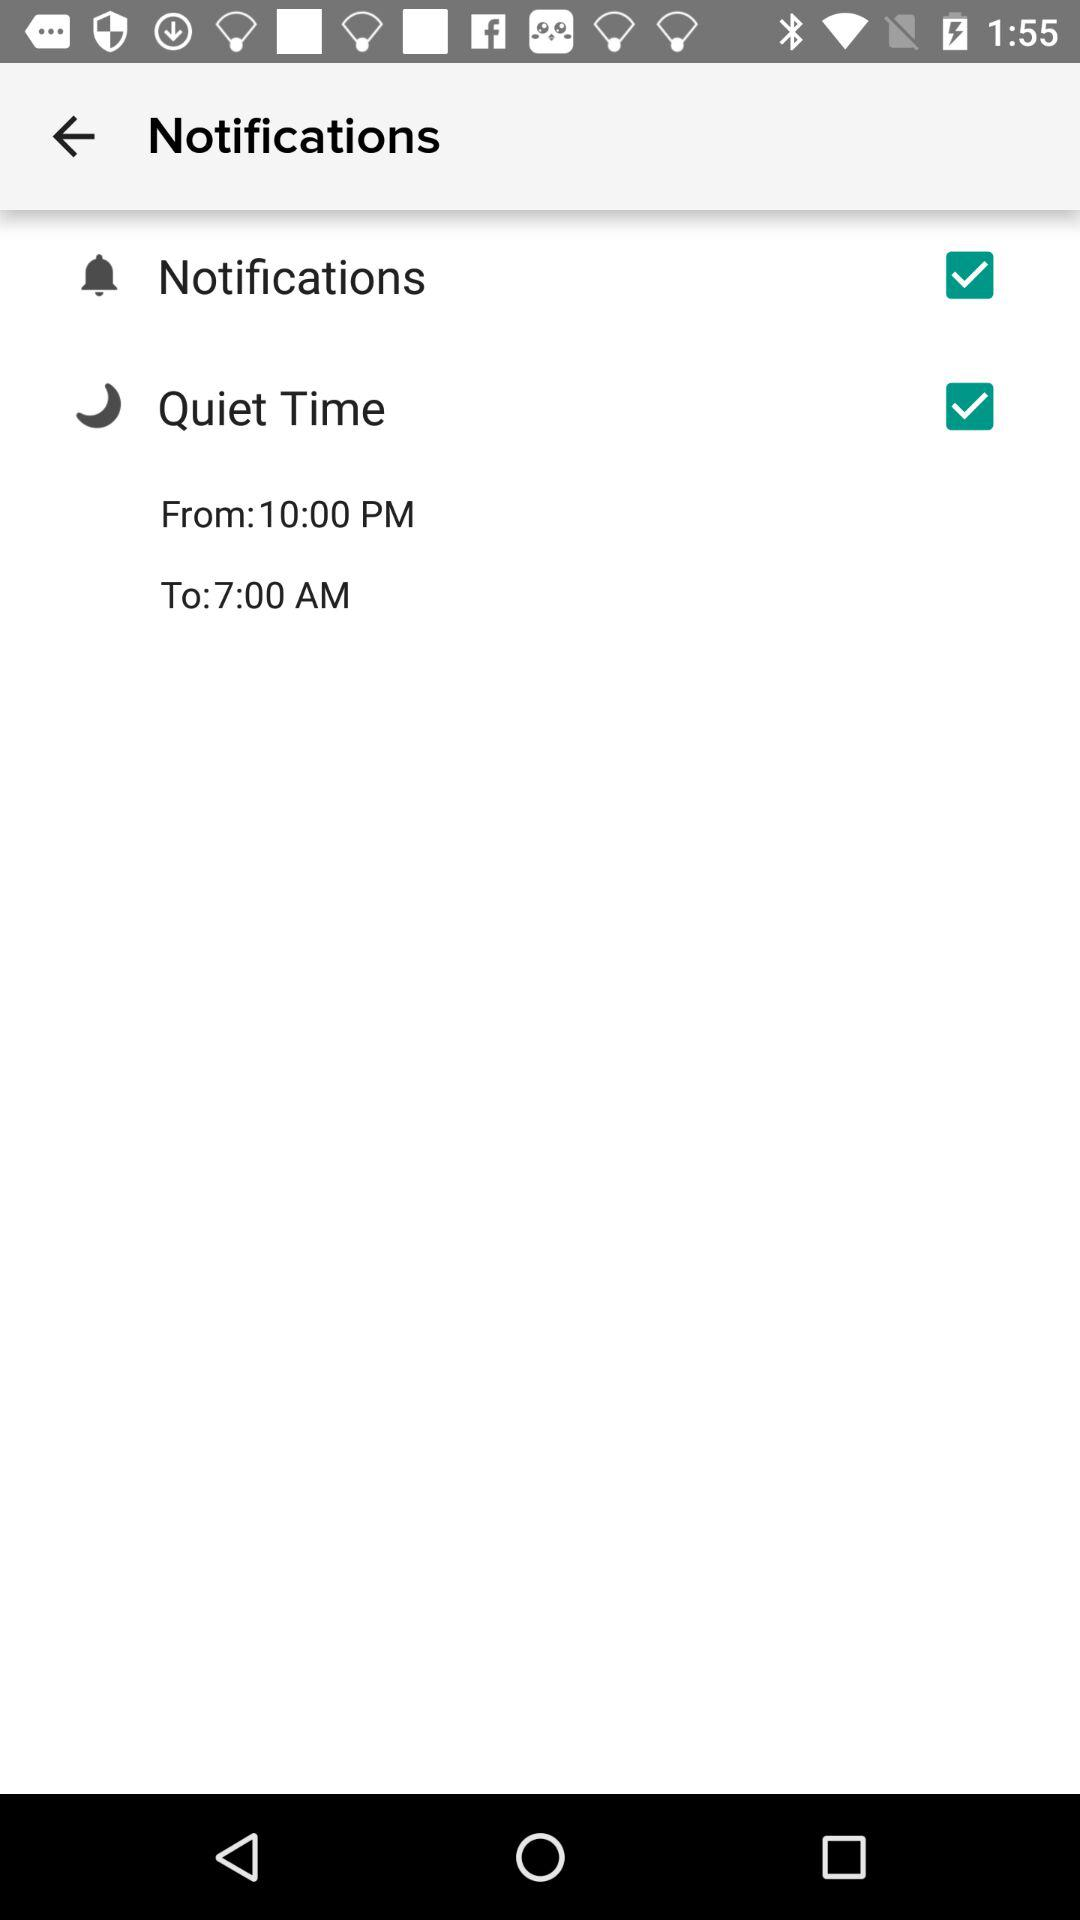What is the end time of "Quiet Time"? The end time of "Quiet Time" is 7:00 AM. 